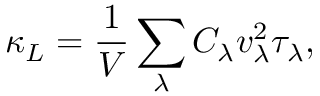Convert formula to latex. <formula><loc_0><loc_0><loc_500><loc_500>\kappa _ { L } = \frac { 1 } { V } \sum _ { \lambda } C _ { \lambda } v _ { \lambda } ^ { 2 } \tau _ { \lambda } ,</formula> 